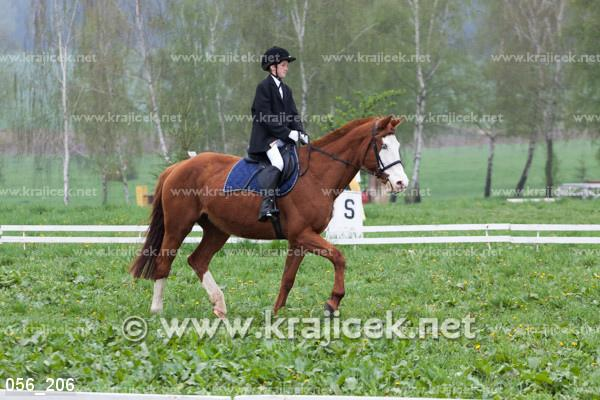What sport is this? Please explain your reasoning. equestrian. The athlete is riding a horse. 